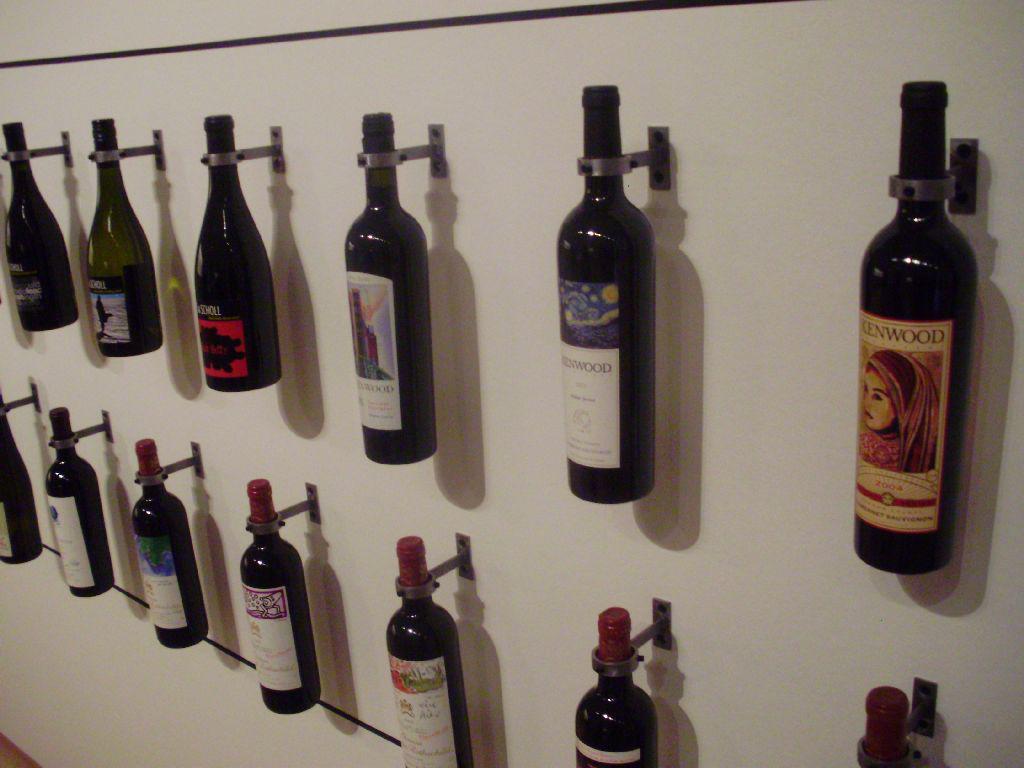Can you describe this image briefly? This picture shows few wine bottles hanging on the board 